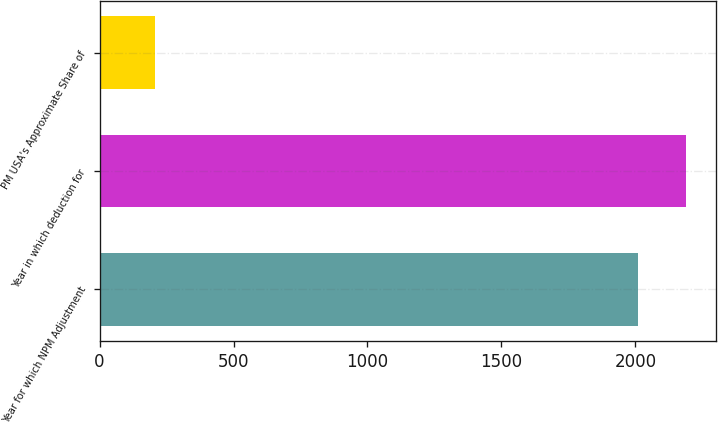Convert chart. <chart><loc_0><loc_0><loc_500><loc_500><bar_chart><fcel>Year for which NPM Adjustment<fcel>Year in which deduction for<fcel>PM USA's Approximate Share of<nl><fcel>2010<fcel>2190.5<fcel>208<nl></chart> 